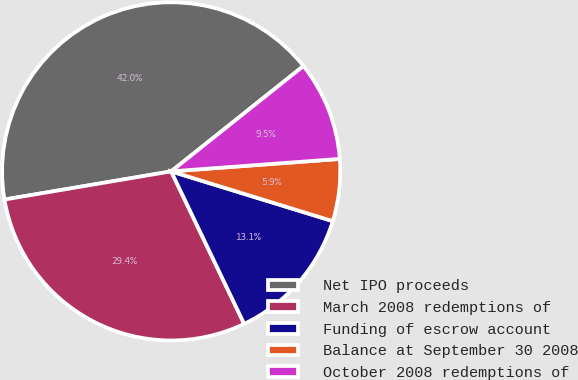Convert chart to OTSL. <chart><loc_0><loc_0><loc_500><loc_500><pie_chart><fcel>Net IPO proceeds<fcel>March 2008 redemptions of<fcel>Funding of escrow account<fcel>Balance at September 30 2008<fcel>October 2008 redemptions of<nl><fcel>41.96%<fcel>29.44%<fcel>13.14%<fcel>5.93%<fcel>9.53%<nl></chart> 